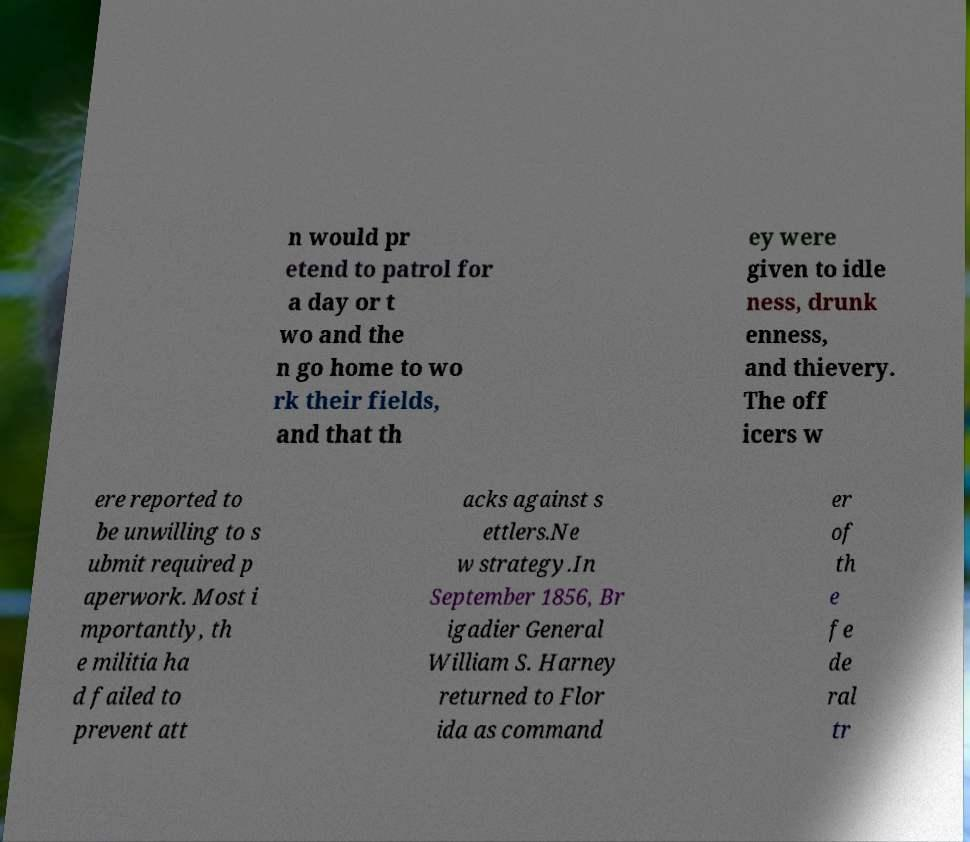There's text embedded in this image that I need extracted. Can you transcribe it verbatim? n would pr etend to patrol for a day or t wo and the n go home to wo rk their fields, and that th ey were given to idle ness, drunk enness, and thievery. The off icers w ere reported to be unwilling to s ubmit required p aperwork. Most i mportantly, th e militia ha d failed to prevent att acks against s ettlers.Ne w strategy.In September 1856, Br igadier General William S. Harney returned to Flor ida as command er of th e fe de ral tr 